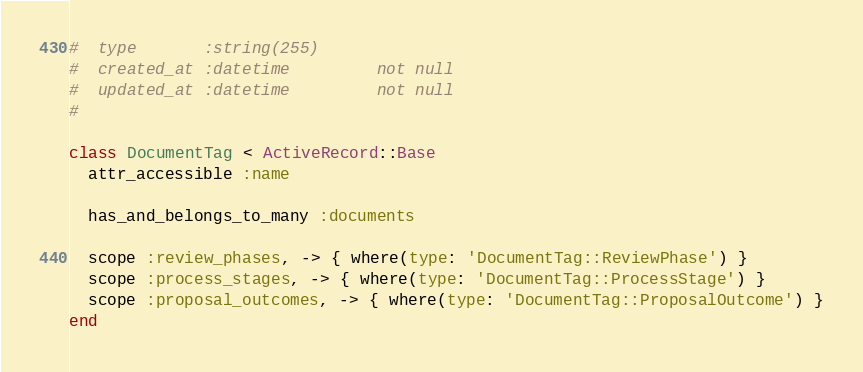Convert code to text. <code><loc_0><loc_0><loc_500><loc_500><_Ruby_>#  type       :string(255)
#  created_at :datetime         not null
#  updated_at :datetime         not null
#

class DocumentTag < ActiveRecord::Base
  attr_accessible :name

  has_and_belongs_to_many :documents

  scope :review_phases, -> { where(type: 'DocumentTag::ReviewPhase') }
  scope :process_stages, -> { where(type: 'DocumentTag::ProcessStage') }
  scope :proposal_outcomes, -> { where(type: 'DocumentTag::ProposalOutcome') }
end
</code> 